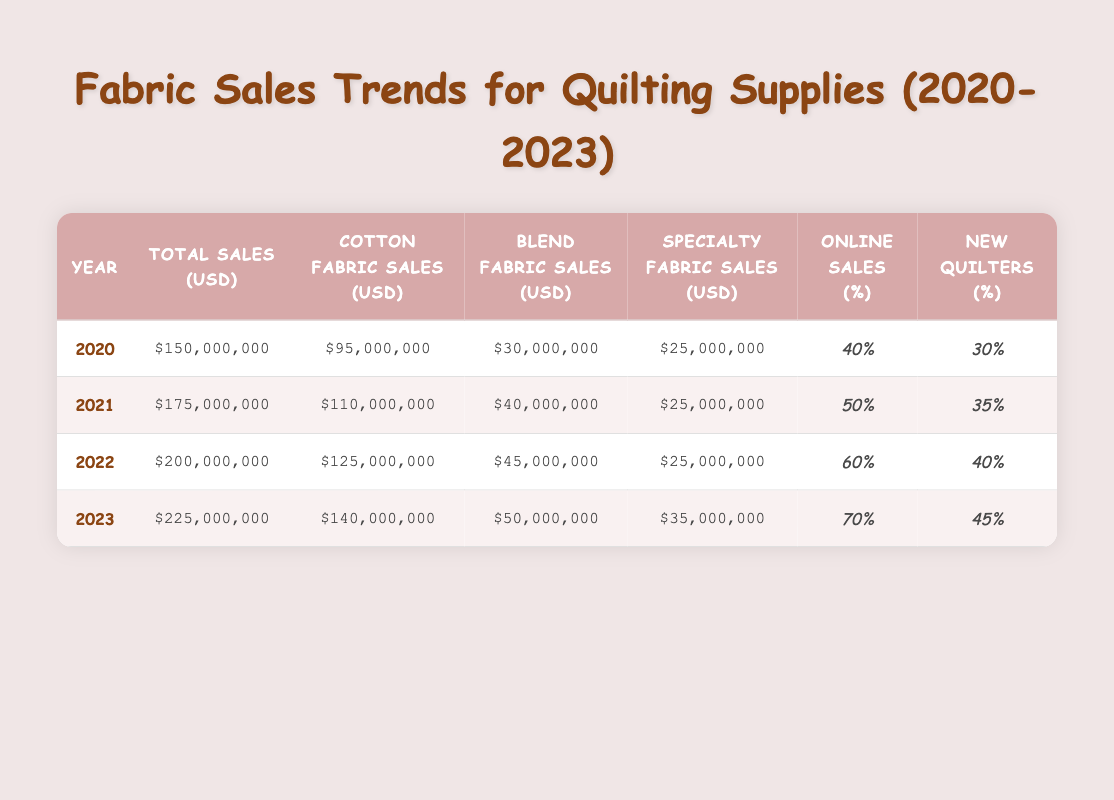What were the total fabric sales in 2021? In the table, we can find the row corresponding to 2021. The Total Sales (USD) column for that year shows $175,000,000.
Answer: $175,000,000 Which year had the highest sales of cotton fabric? To find the highest sales of cotton fabric, we compare the Cotton Fabric Sales (USD) across the years. The highest value is in 2023, where it shows $140,000,000.
Answer: $140,000,000 How much did specialty fabric sales increase from 2020 to 2023? In 2020, Specialty Fabric Sales (USD) were $25,000,000, and in 2023, they were $35,000,000. The increase is calculated as $35,000,000 - $25,000,000 = $10,000,000.
Answer: $10,000,000 True or False: In 2022, online fabric sales made up 60% of the total sales. For the year 2022, the Online Sales Percentage is listed under the respective column, showing 60%. Therefore, the statement is true.
Answer: True What is the average percentage of new quilters from 2020 to 2023? We need to calculate the average of the New Quilters Percentage for each year: (30% + 35% + 40% + 45%) / 4 = 37.5%.
Answer: 37.5% In which year did total sales reach over $200 million for the first time? The total sales crossed $200 million in 2022, as the value shown for that year is $200,000,000. In 2021, the total sales were still below that amount ($175,000,000).
Answer: 2022 How much did blend fabric sales grow from 2021 to 2023? The Blend Fabric Sales (USD) in 2021 were $40,000,000 and in 2023 it increased to $50,000,000. The growth is calculated as $50,000,000 - $40,000,000 = $10,000,000.
Answer: $10,000,000 Is the online sales percentage consistently increasing each year? We check the Online Sales Percentage for each year: 40% in 2020, 50% in 2021, 60% in 2022, and 70% in 2023. Since each value is greater than the previous one, the statement is true.
Answer: True 